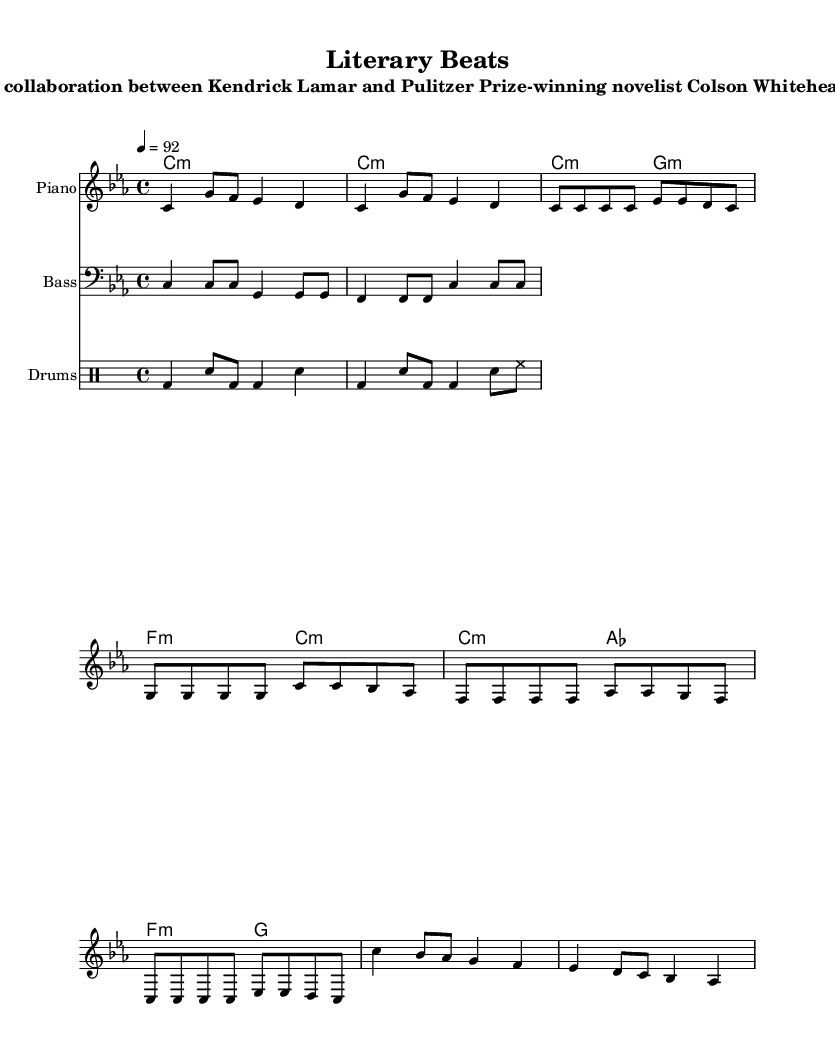What is the key signature of this music? The key signature indicated at the beginning of the score is C minor, which has three flats (Bb, Eb, Ab).
Answer: C minor What is the time signature of this music? The time signature is shown at the beginning and is indicated as 4/4, meaning there are four beats per measure and the quarter note gets one beat.
Answer: 4/4 What is the tempo marking of this piece? The tempo marking is located at the beginning, stating a speed of 92 beats per minute, indicated by the number 4 equals 92.
Answer: 92 How many measures are in the verse section? The verse section has four measures, which can be counted from the staff that outlines that section of music.
Answer: 4 What type of chord is primarily used in the chorus? The chorus primarily uses major chords, specifically the C major, A flat major, F major, and G major chords.
Answer: Major chords How does the bass line interact with the piano in the verse? The bass line follows a rhythmic pattern that complements the piano's harmony, reinforcing the C minor and G minor chords during the verse section.
Answer: Complementary What hip hop elements are present in this composition? The composition includes a rhythmic drum pattern and a bass line that both emphasize the groove typical in hip hop, creating a strong backbeat.
Answer: Strong backbeat 